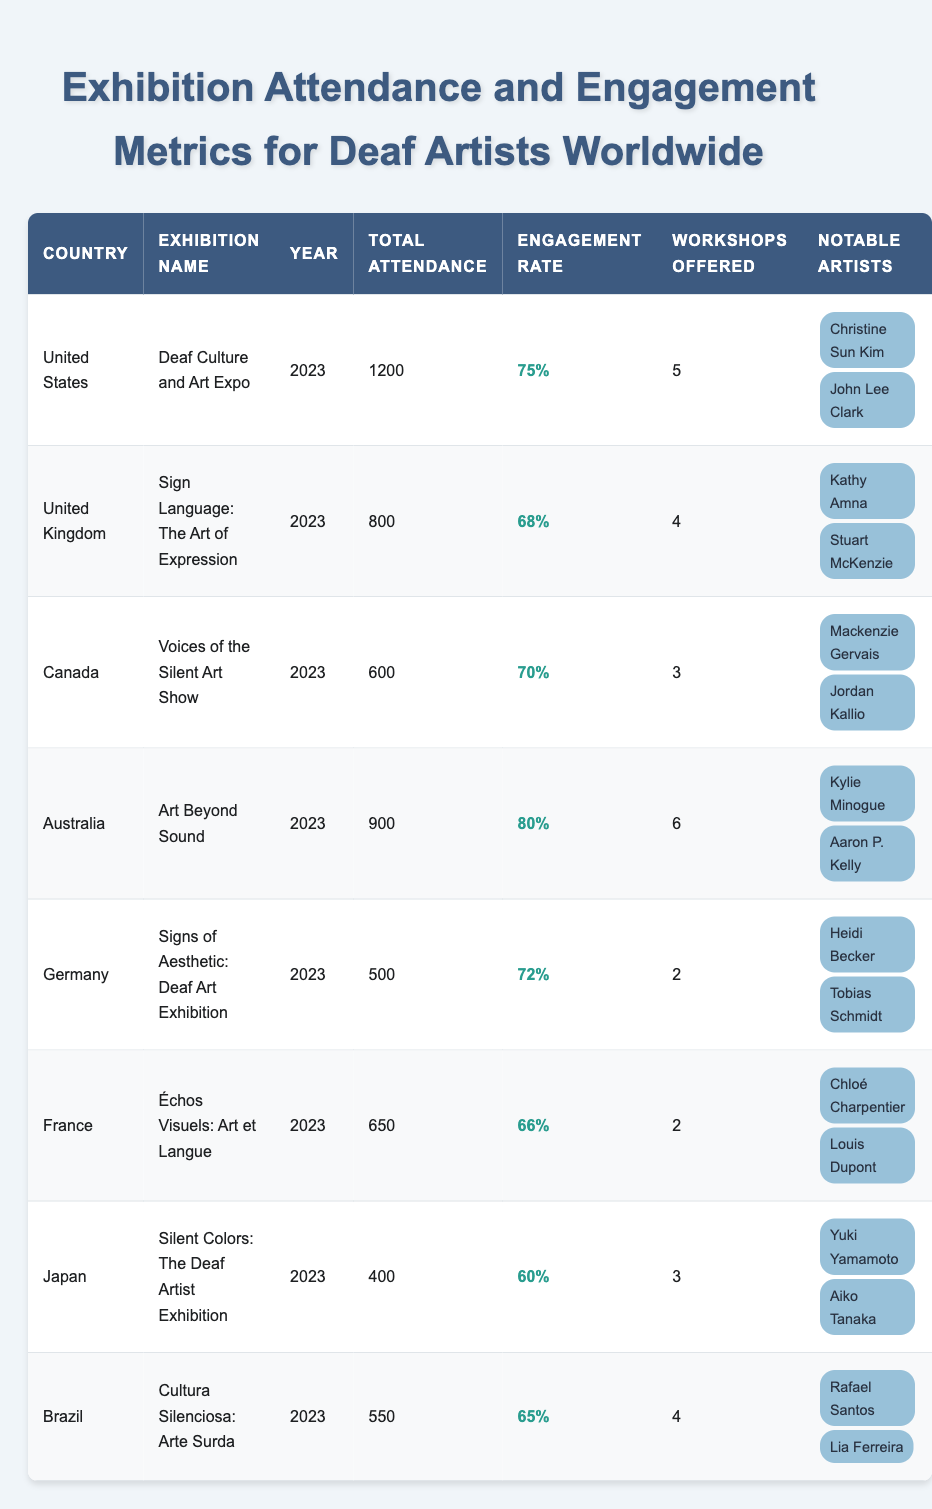What is the total attendance of the exhibition in the United States? The table shows that the total attendance for the "Deaf Culture and Art Expo" in the United States in 2023 is 1200.
Answer: 1200 Which country had the highest engagement rate? By comparing the engagement rates, we see that Australia has the highest rate at 80%.
Answer: Australia What is the engagement rate of the exhibition in Canada? In the table, the engagement rate for the "Voices of the Silent Art Show" in Canada is listed as 70%.
Answer: 70% How many workshops were offered at the exhibition in Germany? The table indicates that there were 2 workshops offered at the "Signs of Aesthetic: Deaf Art Exhibition" in Germany.
Answer: 2 Which notable artist was featured in the United Kingdom's exhibition? "Sign Language: The Art of Expression" in the United Kingdom featured notable artists Kathy Amna and Stuart McKenzie.
Answer: Kathy Amna and Stuart McKenzie What is the total number of workshops offered across all exhibitions? We add the number of workshops offered in each country: 5 (USA) + 4 (UK) + 3 (Canada) + 6 (Australia) + 2 (Germany) + 2 (France) + 3 (Japan) + 4 (Brazil) = 29 workshops.
Answer: 29 Is the engagement rate for the exhibition in Japan above 65%? The engagement rate for Japan is 60%, which is below 65%.
Answer: No What is the median total attendance of the exhibitions? First, we list the total attendance numbers: 1200, 800, 600, 900, 500, 650, 400, 550. Ordering these gives us: 400, 500, 550, 600, 650, 800, 900, 1200. The median (average of the 4th and 5th values) is (600 + 650) / 2 = 625.
Answer: 625 Which exhibition had the least attendance? From the table, the "Silent Colors: The Deaf Artist Exhibition" in Japan had the least attendance at 400.
Answer: 400 How many notable artists were featured in total across all exhibitions? Counting the notable artists for each exhibition: 2 (USA) + 2 (UK) + 2 (Canada) + 2 (Australia) + 2 (Germany) + 2 (France) + 2 (Japan) + 2 (Brazil) totals to 16 notable artists.
Answer: 16 